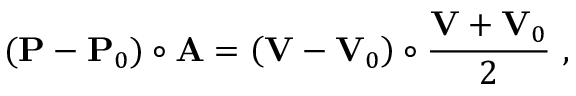Convert formula to latex. <formula><loc_0><loc_0><loc_500><loc_500>( P - P _ { 0 } ) \circ A = \left ( V - V _ { 0 } \right ) \circ { \frac { V + V _ { 0 } } { 2 } } \ ,</formula> 